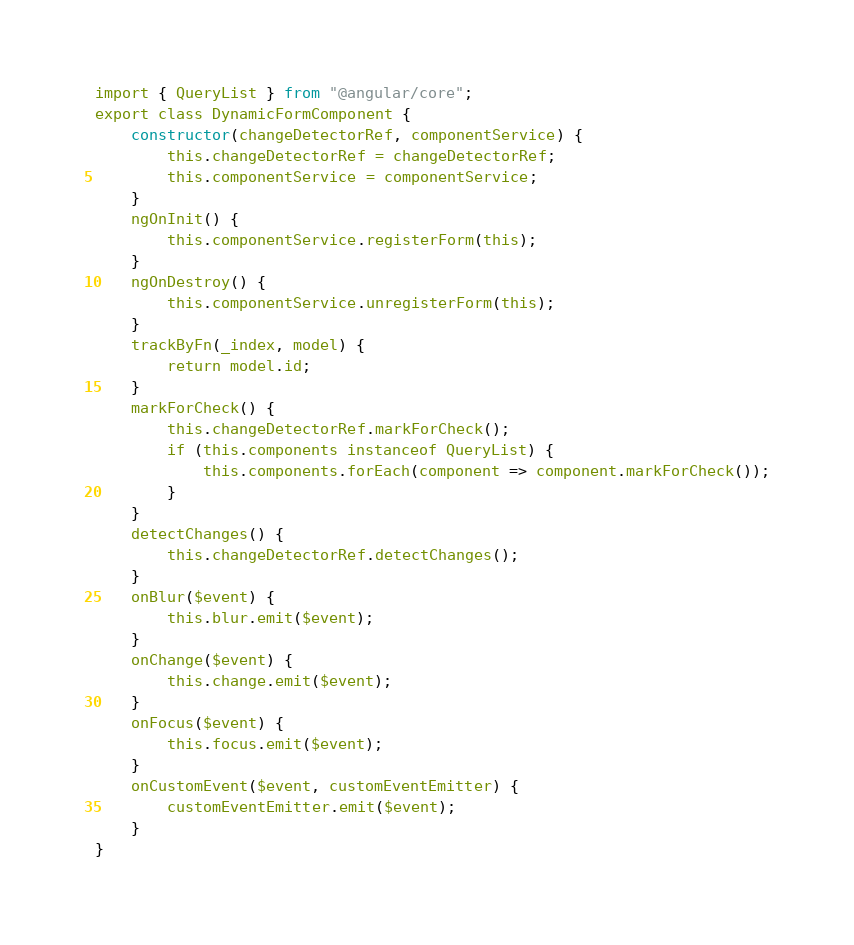Convert code to text. <code><loc_0><loc_0><loc_500><loc_500><_JavaScript_>import { QueryList } from "@angular/core";
export class DynamicFormComponent {
    constructor(changeDetectorRef, componentService) {
        this.changeDetectorRef = changeDetectorRef;
        this.componentService = componentService;
    }
    ngOnInit() {
        this.componentService.registerForm(this);
    }
    ngOnDestroy() {
        this.componentService.unregisterForm(this);
    }
    trackByFn(_index, model) {
        return model.id;
    }
    markForCheck() {
        this.changeDetectorRef.markForCheck();
        if (this.components instanceof QueryList) {
            this.components.forEach(component => component.markForCheck());
        }
    }
    detectChanges() {
        this.changeDetectorRef.detectChanges();
    }
    onBlur($event) {
        this.blur.emit($event);
    }
    onChange($event) {
        this.change.emit($event);
    }
    onFocus($event) {
        this.focus.emit($event);
    }
    onCustomEvent($event, customEventEmitter) {
        customEventEmitter.emit($event);
    }
}</code> 